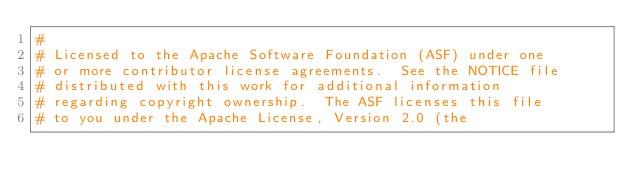Convert code to text. <code><loc_0><loc_0><loc_500><loc_500><_Python_>#
# Licensed to the Apache Software Foundation (ASF) under one
# or more contributor license agreements.  See the NOTICE file
# distributed with this work for additional information
# regarding copyright ownership.  The ASF licenses this file
# to you under the Apache License, Version 2.0 (the</code> 